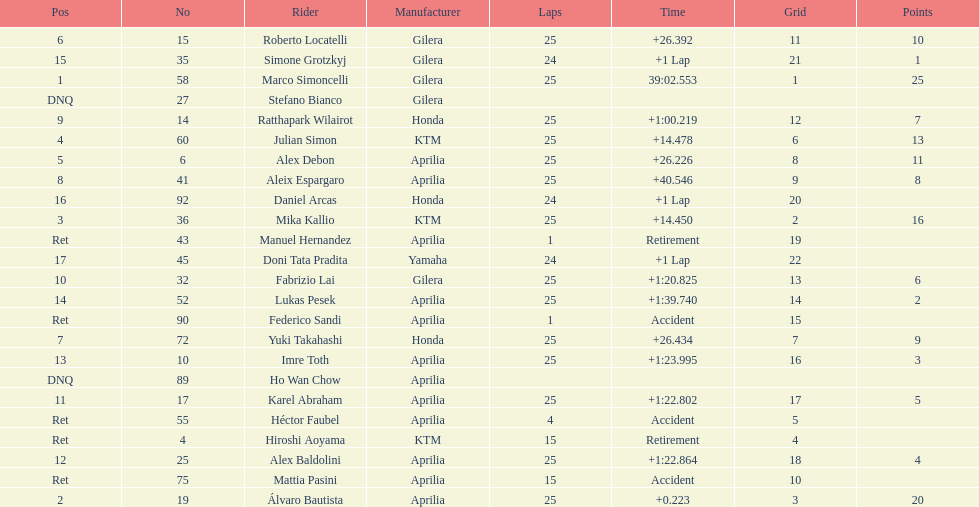How many riders manufacturer is honda? 3. 